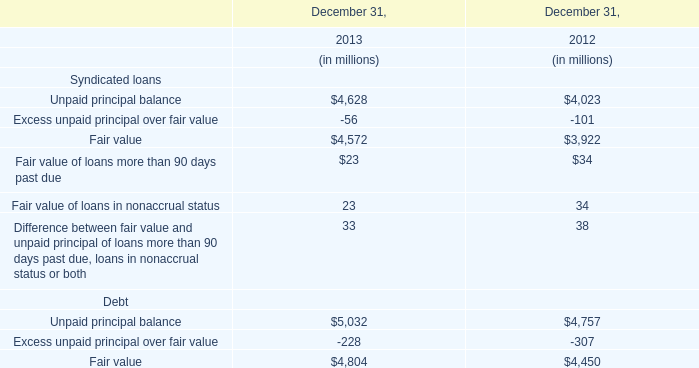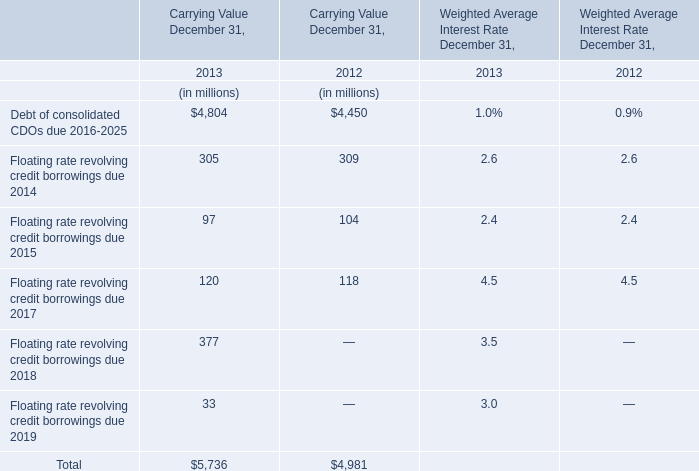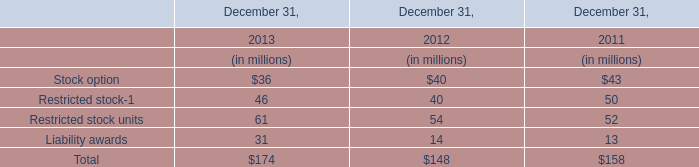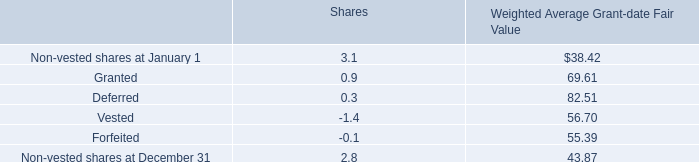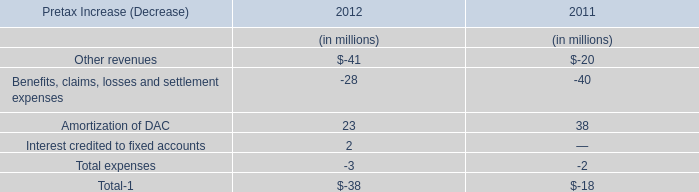Which year the Unpaid principal balance of Syndicated loans is the highest? 
Answer: 2013. 